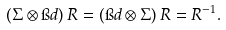Convert formula to latex. <formula><loc_0><loc_0><loc_500><loc_500>( \Sigma \otimes \i d ) \, R = ( \i d \otimes \Sigma ) \, R = R ^ { - 1 } .</formula> 